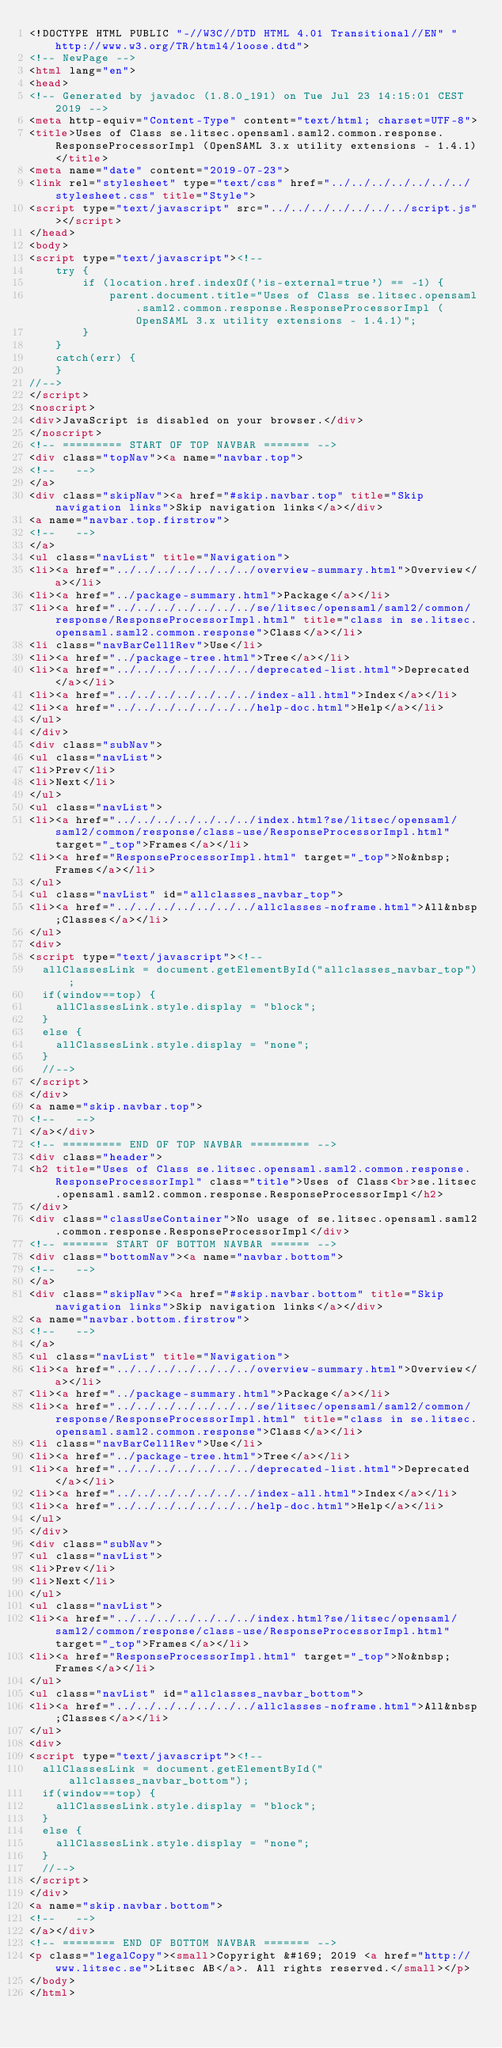<code> <loc_0><loc_0><loc_500><loc_500><_HTML_><!DOCTYPE HTML PUBLIC "-//W3C//DTD HTML 4.01 Transitional//EN" "http://www.w3.org/TR/html4/loose.dtd">
<!-- NewPage -->
<html lang="en">
<head>
<!-- Generated by javadoc (1.8.0_191) on Tue Jul 23 14:15:01 CEST 2019 -->
<meta http-equiv="Content-Type" content="text/html; charset=UTF-8">
<title>Uses of Class se.litsec.opensaml.saml2.common.response.ResponseProcessorImpl (OpenSAML 3.x utility extensions - 1.4.1)</title>
<meta name="date" content="2019-07-23">
<link rel="stylesheet" type="text/css" href="../../../../../../../stylesheet.css" title="Style">
<script type="text/javascript" src="../../../../../../../script.js"></script>
</head>
<body>
<script type="text/javascript"><!--
    try {
        if (location.href.indexOf('is-external=true') == -1) {
            parent.document.title="Uses of Class se.litsec.opensaml.saml2.common.response.ResponseProcessorImpl (OpenSAML 3.x utility extensions - 1.4.1)";
        }
    }
    catch(err) {
    }
//-->
</script>
<noscript>
<div>JavaScript is disabled on your browser.</div>
</noscript>
<!-- ========= START OF TOP NAVBAR ======= -->
<div class="topNav"><a name="navbar.top">
<!--   -->
</a>
<div class="skipNav"><a href="#skip.navbar.top" title="Skip navigation links">Skip navigation links</a></div>
<a name="navbar.top.firstrow">
<!--   -->
</a>
<ul class="navList" title="Navigation">
<li><a href="../../../../../../../overview-summary.html">Overview</a></li>
<li><a href="../package-summary.html">Package</a></li>
<li><a href="../../../../../../../se/litsec/opensaml/saml2/common/response/ResponseProcessorImpl.html" title="class in se.litsec.opensaml.saml2.common.response">Class</a></li>
<li class="navBarCell1Rev">Use</li>
<li><a href="../package-tree.html">Tree</a></li>
<li><a href="../../../../../../../deprecated-list.html">Deprecated</a></li>
<li><a href="../../../../../../../index-all.html">Index</a></li>
<li><a href="../../../../../../../help-doc.html">Help</a></li>
</ul>
</div>
<div class="subNav">
<ul class="navList">
<li>Prev</li>
<li>Next</li>
</ul>
<ul class="navList">
<li><a href="../../../../../../../index.html?se/litsec/opensaml/saml2/common/response/class-use/ResponseProcessorImpl.html" target="_top">Frames</a></li>
<li><a href="ResponseProcessorImpl.html" target="_top">No&nbsp;Frames</a></li>
</ul>
<ul class="navList" id="allclasses_navbar_top">
<li><a href="../../../../../../../allclasses-noframe.html">All&nbsp;Classes</a></li>
</ul>
<div>
<script type="text/javascript"><!--
  allClassesLink = document.getElementById("allclasses_navbar_top");
  if(window==top) {
    allClassesLink.style.display = "block";
  }
  else {
    allClassesLink.style.display = "none";
  }
  //-->
</script>
</div>
<a name="skip.navbar.top">
<!--   -->
</a></div>
<!-- ========= END OF TOP NAVBAR ========= -->
<div class="header">
<h2 title="Uses of Class se.litsec.opensaml.saml2.common.response.ResponseProcessorImpl" class="title">Uses of Class<br>se.litsec.opensaml.saml2.common.response.ResponseProcessorImpl</h2>
</div>
<div class="classUseContainer">No usage of se.litsec.opensaml.saml2.common.response.ResponseProcessorImpl</div>
<!-- ======= START OF BOTTOM NAVBAR ====== -->
<div class="bottomNav"><a name="navbar.bottom">
<!--   -->
</a>
<div class="skipNav"><a href="#skip.navbar.bottom" title="Skip navigation links">Skip navigation links</a></div>
<a name="navbar.bottom.firstrow">
<!--   -->
</a>
<ul class="navList" title="Navigation">
<li><a href="../../../../../../../overview-summary.html">Overview</a></li>
<li><a href="../package-summary.html">Package</a></li>
<li><a href="../../../../../../../se/litsec/opensaml/saml2/common/response/ResponseProcessorImpl.html" title="class in se.litsec.opensaml.saml2.common.response">Class</a></li>
<li class="navBarCell1Rev">Use</li>
<li><a href="../package-tree.html">Tree</a></li>
<li><a href="../../../../../../../deprecated-list.html">Deprecated</a></li>
<li><a href="../../../../../../../index-all.html">Index</a></li>
<li><a href="../../../../../../../help-doc.html">Help</a></li>
</ul>
</div>
<div class="subNav">
<ul class="navList">
<li>Prev</li>
<li>Next</li>
</ul>
<ul class="navList">
<li><a href="../../../../../../../index.html?se/litsec/opensaml/saml2/common/response/class-use/ResponseProcessorImpl.html" target="_top">Frames</a></li>
<li><a href="ResponseProcessorImpl.html" target="_top">No&nbsp;Frames</a></li>
</ul>
<ul class="navList" id="allclasses_navbar_bottom">
<li><a href="../../../../../../../allclasses-noframe.html">All&nbsp;Classes</a></li>
</ul>
<div>
<script type="text/javascript"><!--
  allClassesLink = document.getElementById("allclasses_navbar_bottom");
  if(window==top) {
    allClassesLink.style.display = "block";
  }
  else {
    allClassesLink.style.display = "none";
  }
  //-->
</script>
</div>
<a name="skip.navbar.bottom">
<!--   -->
</a></div>
<!-- ======== END OF BOTTOM NAVBAR ======= -->
<p class="legalCopy"><small>Copyright &#169; 2019 <a href="http://www.litsec.se">Litsec AB</a>. All rights reserved.</small></p>
</body>
</html>
</code> 